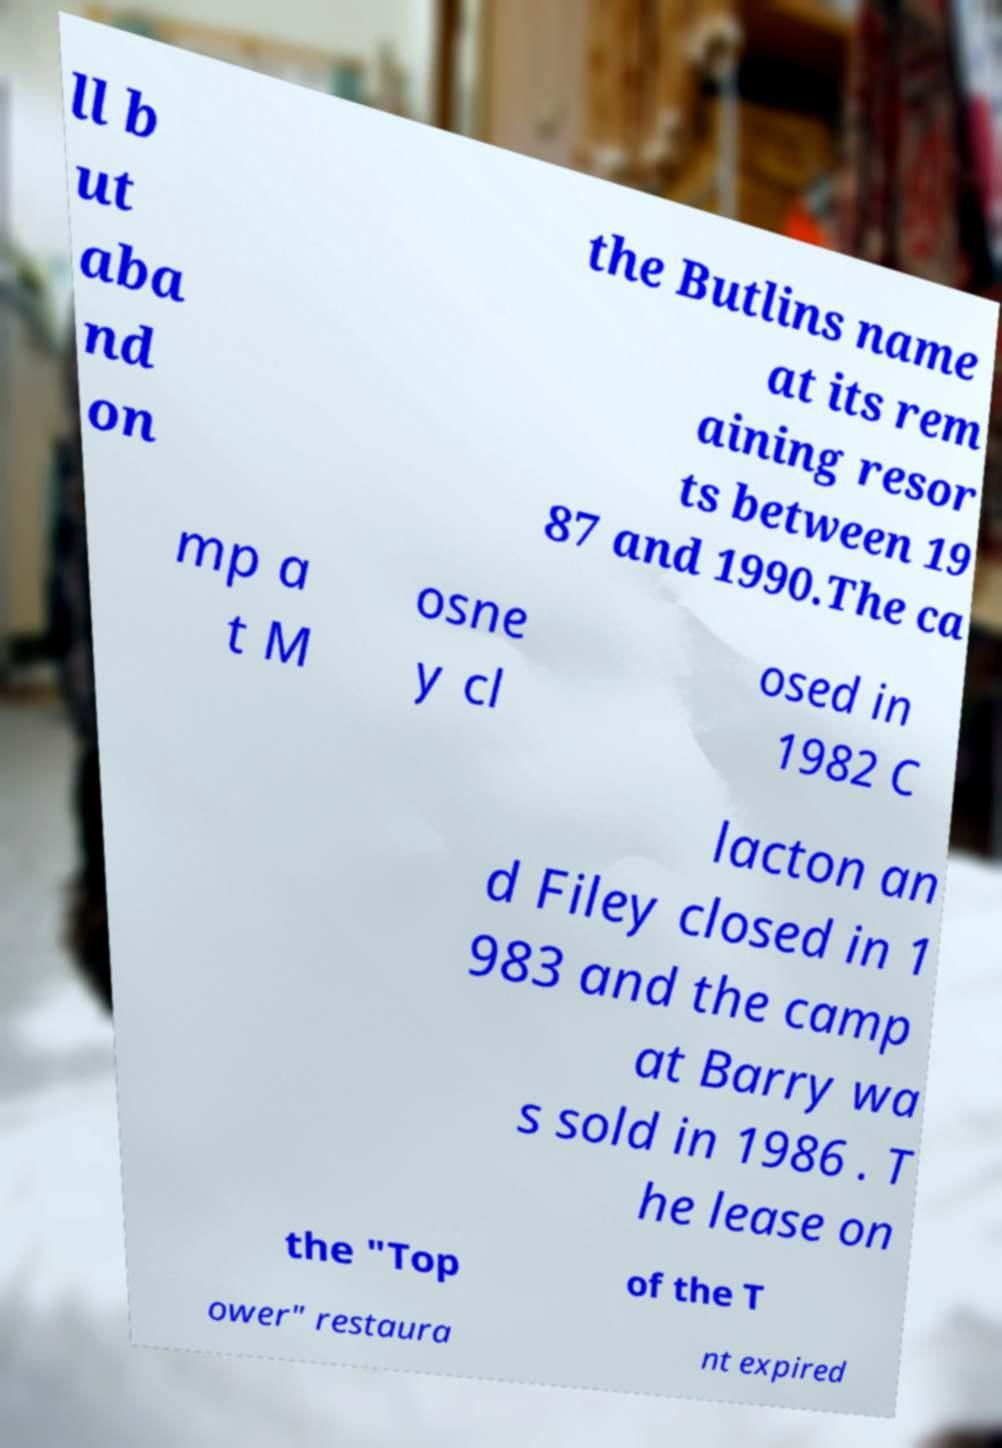Please read and relay the text visible in this image. What does it say? ll b ut aba nd on the Butlins name at its rem aining resor ts between 19 87 and 1990.The ca mp a t M osne y cl osed in 1982 C lacton an d Filey closed in 1 983 and the camp at Barry wa s sold in 1986 . T he lease on the "Top of the T ower" restaura nt expired 